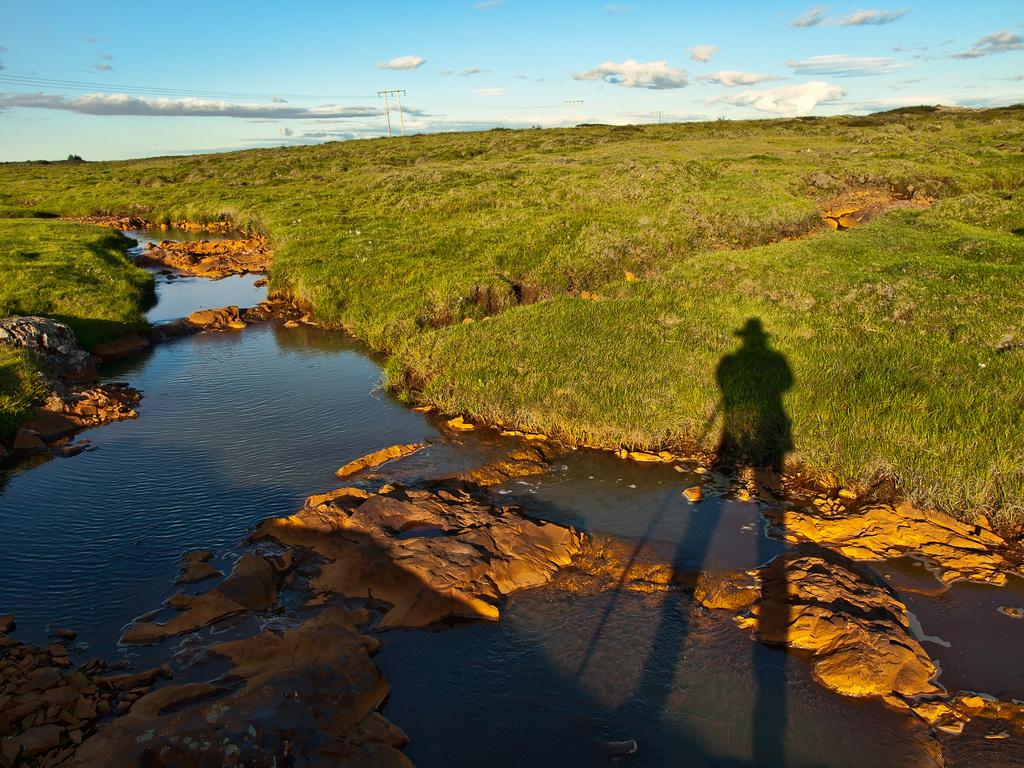What type of landscape is depicted in the image? There is a grassland in the image. What structures can be seen in the grassland? There are poles connected with wires in the image. What is visible at the bottom of the water in the image? There are rocks at the bottom of the water in the image. What is visible at the top of the image? The sky is visible at the top of the image. What can be seen in the sky? There are clouds in the sky. How many holes can be seen in the mountain in the image? There is no mountain present in the image, so there are no holes to count. What type of cough is the person in the image experiencing? There are no people or coughs mentioned in the image. 